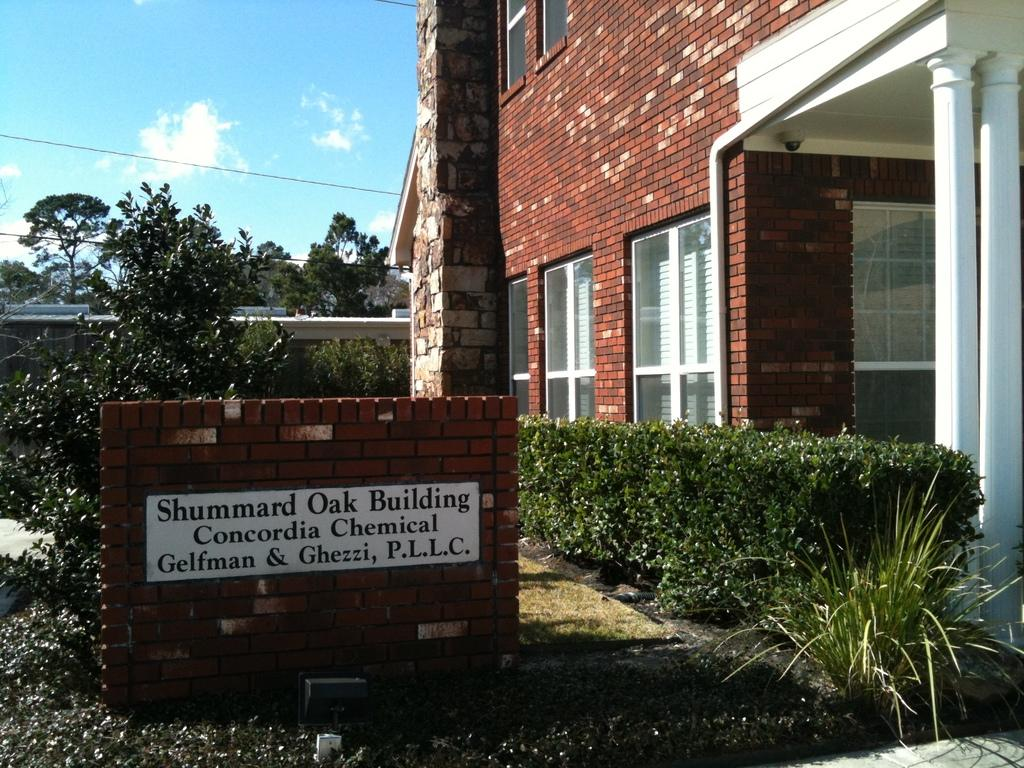What is on the brick wall in the image? There is a name board on a brick wall in the image. What type of vegetation can be seen in the image? There are plants and trees in the image. What type of structure is visible in the image? There is a house in the image. What architectural feature can be seen in the house? There are glass windows and pillars in the image. What is visible in the background of the image? The background of the image includes a bridge and the sky. What type of neck accessory is worn by the bridge in the image? There are no neck accessories present in the image, as the bridge is an inanimate object. What type of shock can be seen affecting the plants in the image? There is no shock present in the image; the plants appear to be healthy and unaffected. 